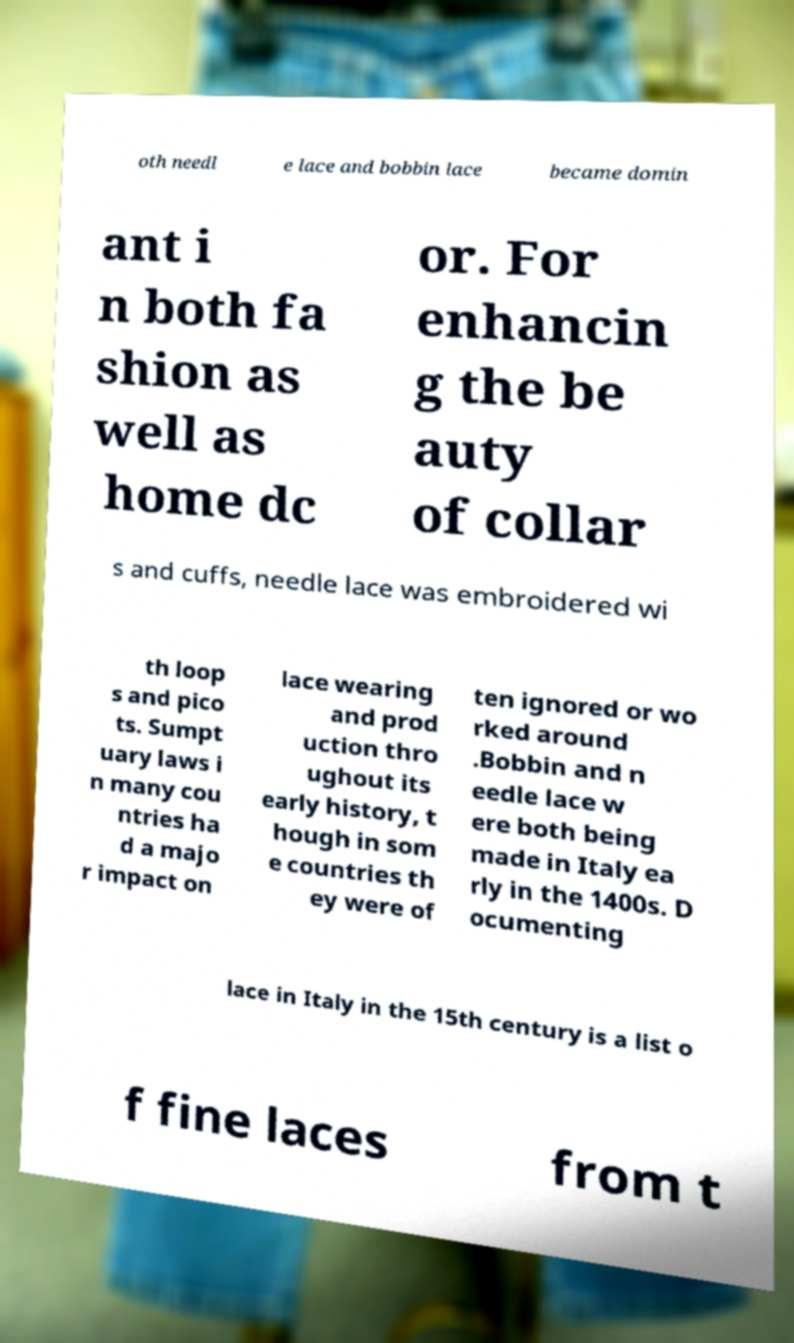There's text embedded in this image that I need extracted. Can you transcribe it verbatim? oth needl e lace and bobbin lace became domin ant i n both fa shion as well as home dc or. For enhancin g the be auty of collar s and cuffs, needle lace was embroidered wi th loop s and pico ts. Sumpt uary laws i n many cou ntries ha d a majo r impact on lace wearing and prod uction thro ughout its early history, t hough in som e countries th ey were of ten ignored or wo rked around .Bobbin and n eedle lace w ere both being made in Italy ea rly in the 1400s. D ocumenting lace in Italy in the 15th century is a list o f fine laces from t 